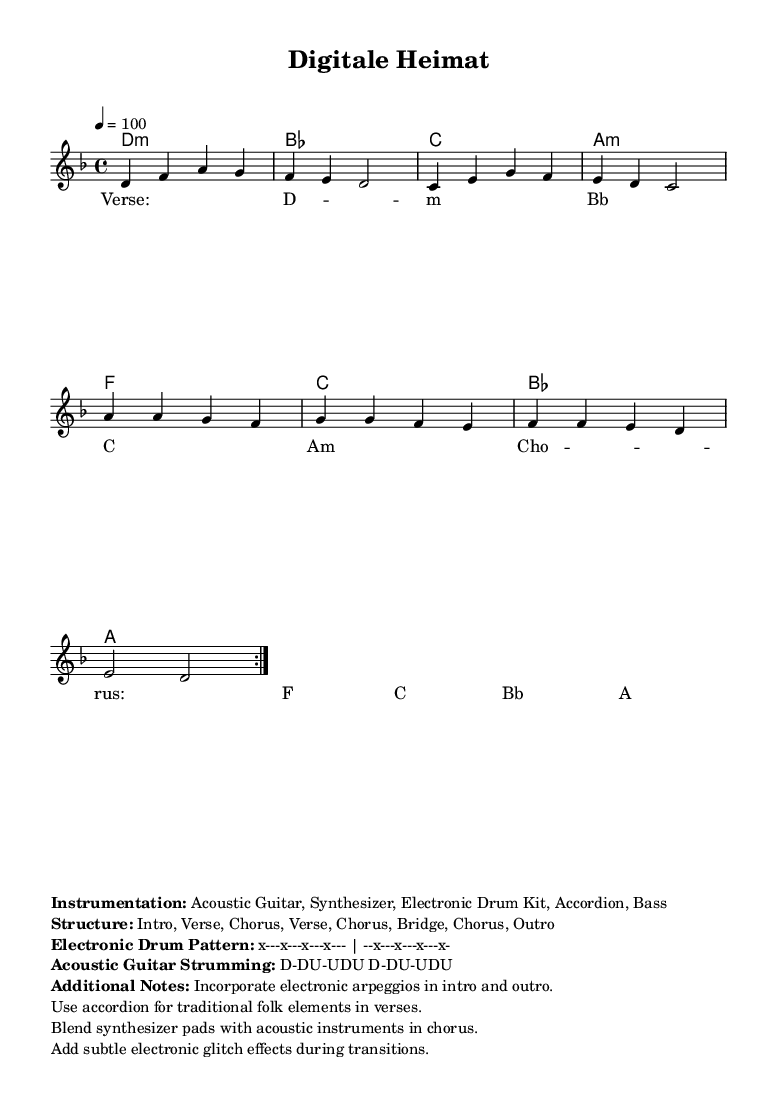What is the key signature of this music? The key signature shows two flats at the beginning, indicating that the music is in D minor.
Answer: D minor What is the time signature of this piece? The time signature is noted at the beginning of the score as 4/4, indicating four beats per measure.
Answer: 4/4 What is the tempo marking given in the score? The tempo marking specifies "4 = 100," meaning there should be 100 beats per minute.
Answer: 100 What is the structure of the song? The structure is listed in the markup section, outlining the order of sections including intro, verses, choruses, bridge, and outro.
Answer: Intro, Verse, Chorus, Verse, Chorus, Bridge, Chorus, Outro Which instruments are specified for this piece? The markup includes a list of instruments, highlighting acoustic guitar, synthesizer, electronic drum kit, accordion, and bass as the instrumentation.
Answer: Acoustic Guitar, Synthesizer, Electronic Drum Kit, Accordion, Bass What type of electronic element is suggested in the intro and outro? The additional notes mention incorporating electronic arpeggios in both the intro and outro sections of the piece.
Answer: Electronic arpeggios How many times is the verse repeated? In the structure section, it indicates that the verse is repeated two times during the performance of the song.
Answer: 2 times 